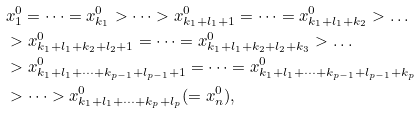Convert formula to latex. <formula><loc_0><loc_0><loc_500><loc_500>& x _ { 1 } ^ { 0 } = \dots = x _ { k _ { 1 } } ^ { 0 } > \dots > x _ { k _ { 1 } + l _ { 1 } + 1 } ^ { 0 } = \dots = x _ { k _ { 1 } + l _ { 1 } + k _ { 2 } } ^ { 0 } > \dots \\ & > x _ { k _ { 1 } + l _ { 1 } + k _ { 2 } + l _ { 2 } + 1 } ^ { 0 } = \dots = x _ { k _ { 1 } + l _ { 1 } + k _ { 2 } + l _ { 2 } + k _ { 3 } } ^ { 0 } > \dots \\ & > x _ { k _ { 1 } + l _ { 1 } + \dots + k _ { p - 1 } + l _ { p - 1 } + 1 } ^ { 0 } = \dots = x _ { k _ { 1 } + l _ { 1 } + \dots + k _ { p - 1 } + l _ { p - 1 } + k _ { p } } ^ { 0 } \\ & > \dots > x ^ { 0 } _ { k _ { 1 } + l _ { 1 } + \dots + k _ { p } + l _ { p } } ( = x ^ { 0 } _ { n } ) ,</formula> 